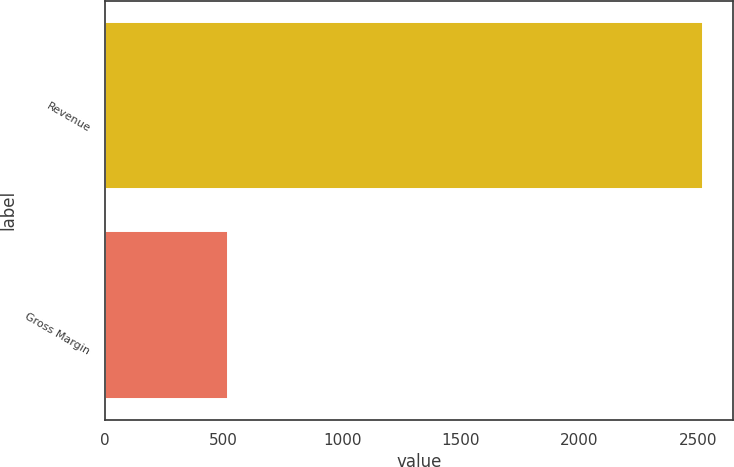Convert chart. <chart><loc_0><loc_0><loc_500><loc_500><bar_chart><fcel>Revenue<fcel>Gross Margin<nl><fcel>2519<fcel>519<nl></chart> 